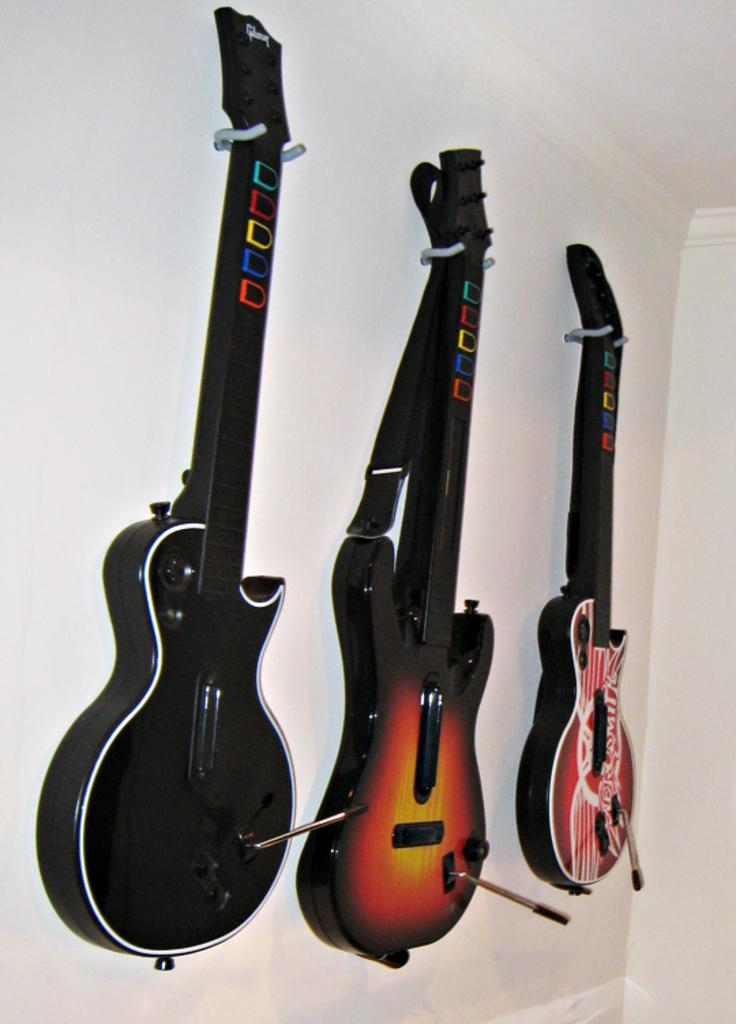How many guitars are visible in the image? There are three guitars in the image. Where are the guitars located in the image? The guitars are hanging on a wall. What type of government is depicted in the image? There is no government depicted in the image; it features three guitars hanging on a wall. Can you see any umbrellas in the image? There are no umbrellas present in the image. 